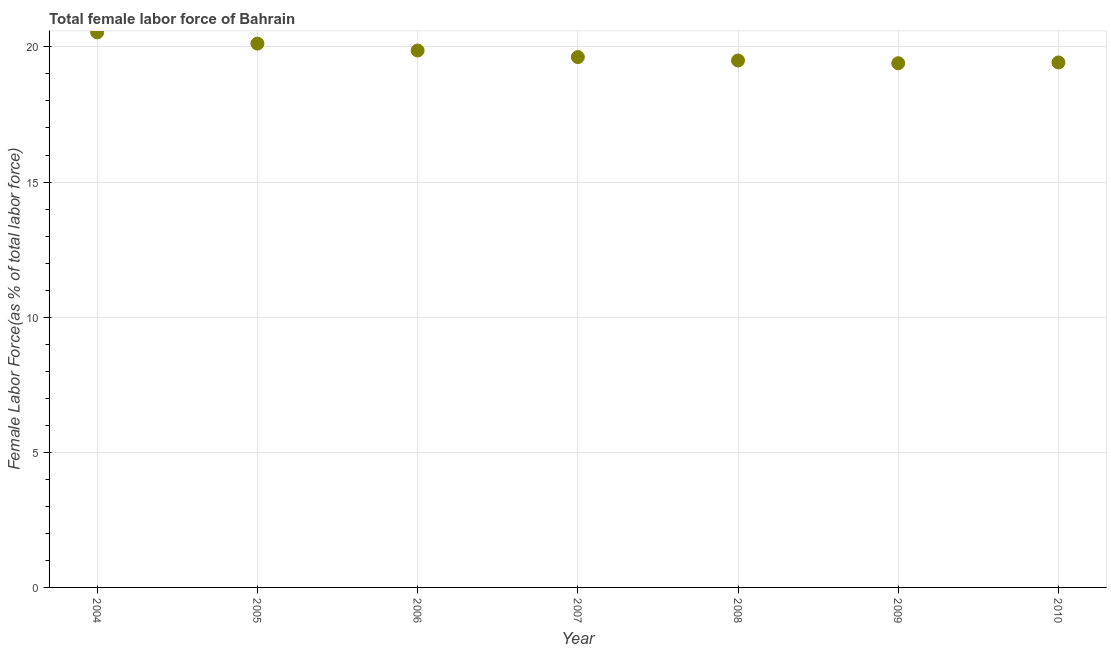What is the total female labor force in 2008?
Your response must be concise. 19.5. Across all years, what is the maximum total female labor force?
Offer a very short reply. 20.54. Across all years, what is the minimum total female labor force?
Provide a short and direct response. 19.4. In which year was the total female labor force maximum?
Your answer should be very brief. 2004. In which year was the total female labor force minimum?
Your answer should be compact. 2009. What is the sum of the total female labor force?
Ensure brevity in your answer.  138.47. What is the difference between the total female labor force in 2004 and 2005?
Offer a terse response. 0.41. What is the average total female labor force per year?
Offer a very short reply. 19.78. What is the median total female labor force?
Your answer should be compact. 19.62. In how many years, is the total female labor force greater than 8 %?
Ensure brevity in your answer.  7. What is the ratio of the total female labor force in 2004 to that in 2006?
Keep it short and to the point. 1.03. Is the total female labor force in 2007 less than that in 2010?
Make the answer very short. No. What is the difference between the highest and the second highest total female labor force?
Your answer should be very brief. 0.41. What is the difference between the highest and the lowest total female labor force?
Your response must be concise. 1.14. How many years are there in the graph?
Offer a very short reply. 7. What is the difference between two consecutive major ticks on the Y-axis?
Provide a succinct answer. 5. Does the graph contain any zero values?
Provide a short and direct response. No. Does the graph contain grids?
Provide a short and direct response. Yes. What is the title of the graph?
Keep it short and to the point. Total female labor force of Bahrain. What is the label or title of the Y-axis?
Offer a terse response. Female Labor Force(as % of total labor force). What is the Female Labor Force(as % of total labor force) in 2004?
Provide a short and direct response. 20.54. What is the Female Labor Force(as % of total labor force) in 2005?
Make the answer very short. 20.12. What is the Female Labor Force(as % of total labor force) in 2006?
Your answer should be very brief. 19.87. What is the Female Labor Force(as % of total labor force) in 2007?
Provide a short and direct response. 19.62. What is the Female Labor Force(as % of total labor force) in 2008?
Keep it short and to the point. 19.5. What is the Female Labor Force(as % of total labor force) in 2009?
Provide a short and direct response. 19.4. What is the Female Labor Force(as % of total labor force) in 2010?
Your answer should be compact. 19.42. What is the difference between the Female Labor Force(as % of total labor force) in 2004 and 2005?
Your answer should be very brief. 0.41. What is the difference between the Female Labor Force(as % of total labor force) in 2004 and 2006?
Provide a succinct answer. 0.67. What is the difference between the Female Labor Force(as % of total labor force) in 2004 and 2007?
Give a very brief answer. 0.91. What is the difference between the Female Labor Force(as % of total labor force) in 2004 and 2008?
Offer a terse response. 1.04. What is the difference between the Female Labor Force(as % of total labor force) in 2004 and 2009?
Provide a short and direct response. 1.14. What is the difference between the Female Labor Force(as % of total labor force) in 2004 and 2010?
Provide a succinct answer. 1.11. What is the difference between the Female Labor Force(as % of total labor force) in 2005 and 2006?
Ensure brevity in your answer.  0.26. What is the difference between the Female Labor Force(as % of total labor force) in 2005 and 2007?
Offer a terse response. 0.5. What is the difference between the Female Labor Force(as % of total labor force) in 2005 and 2008?
Provide a short and direct response. 0.63. What is the difference between the Female Labor Force(as % of total labor force) in 2005 and 2009?
Provide a succinct answer. 0.73. What is the difference between the Female Labor Force(as % of total labor force) in 2005 and 2010?
Ensure brevity in your answer.  0.7. What is the difference between the Female Labor Force(as % of total labor force) in 2006 and 2007?
Make the answer very short. 0.24. What is the difference between the Female Labor Force(as % of total labor force) in 2006 and 2008?
Provide a short and direct response. 0.37. What is the difference between the Female Labor Force(as % of total labor force) in 2006 and 2009?
Keep it short and to the point. 0.47. What is the difference between the Female Labor Force(as % of total labor force) in 2006 and 2010?
Give a very brief answer. 0.44. What is the difference between the Female Labor Force(as % of total labor force) in 2007 and 2008?
Your answer should be compact. 0.13. What is the difference between the Female Labor Force(as % of total labor force) in 2007 and 2009?
Offer a terse response. 0.23. What is the difference between the Female Labor Force(as % of total labor force) in 2007 and 2010?
Offer a very short reply. 0.2. What is the difference between the Female Labor Force(as % of total labor force) in 2008 and 2009?
Your answer should be very brief. 0.1. What is the difference between the Female Labor Force(as % of total labor force) in 2008 and 2010?
Offer a terse response. 0.07. What is the difference between the Female Labor Force(as % of total labor force) in 2009 and 2010?
Offer a terse response. -0.03. What is the ratio of the Female Labor Force(as % of total labor force) in 2004 to that in 2006?
Offer a very short reply. 1.03. What is the ratio of the Female Labor Force(as % of total labor force) in 2004 to that in 2007?
Your response must be concise. 1.05. What is the ratio of the Female Labor Force(as % of total labor force) in 2004 to that in 2008?
Provide a succinct answer. 1.05. What is the ratio of the Female Labor Force(as % of total labor force) in 2004 to that in 2009?
Provide a short and direct response. 1.06. What is the ratio of the Female Labor Force(as % of total labor force) in 2004 to that in 2010?
Your answer should be compact. 1.06. What is the ratio of the Female Labor Force(as % of total labor force) in 2005 to that in 2008?
Your response must be concise. 1.03. What is the ratio of the Female Labor Force(as % of total labor force) in 2005 to that in 2009?
Keep it short and to the point. 1.04. What is the ratio of the Female Labor Force(as % of total labor force) in 2005 to that in 2010?
Your answer should be compact. 1.04. What is the ratio of the Female Labor Force(as % of total labor force) in 2006 to that in 2008?
Your answer should be compact. 1.02. What is the ratio of the Female Labor Force(as % of total labor force) in 2006 to that in 2009?
Provide a short and direct response. 1.02. What is the ratio of the Female Labor Force(as % of total labor force) in 2008 to that in 2009?
Keep it short and to the point. 1. What is the ratio of the Female Labor Force(as % of total labor force) in 2008 to that in 2010?
Ensure brevity in your answer.  1. What is the ratio of the Female Labor Force(as % of total labor force) in 2009 to that in 2010?
Your response must be concise. 1. 